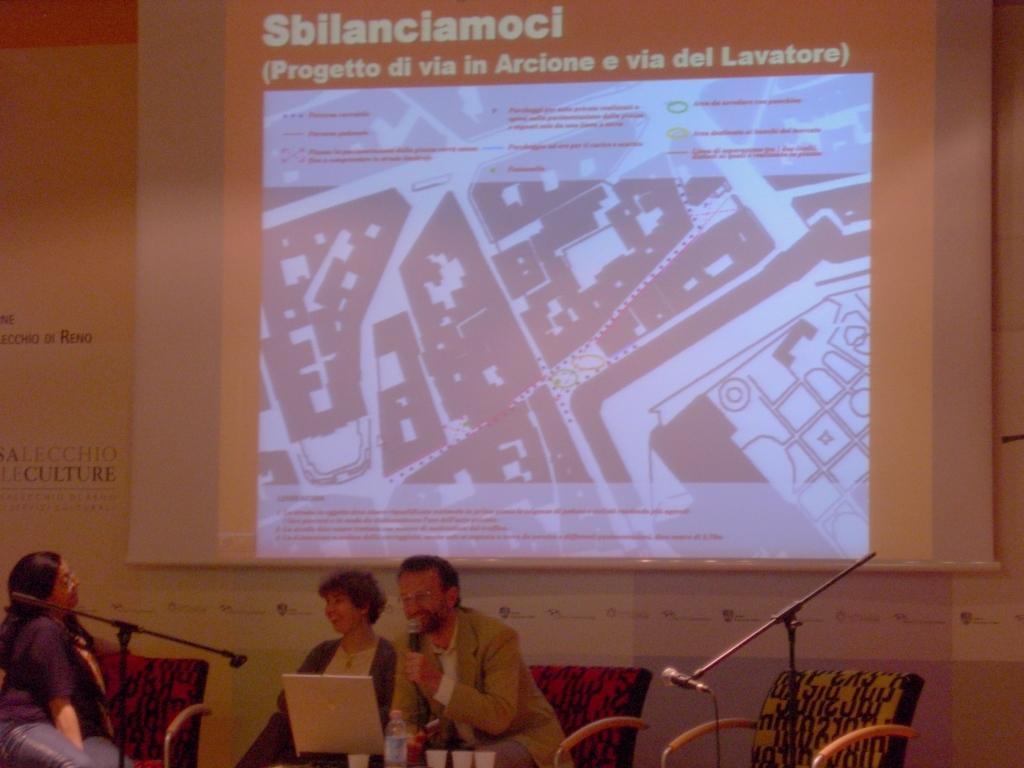Could you give a brief overview of what you see in this image? In this image we can see three people in the image. A man is holding a microphone and speaking into it. There is a projector screen in the image. 